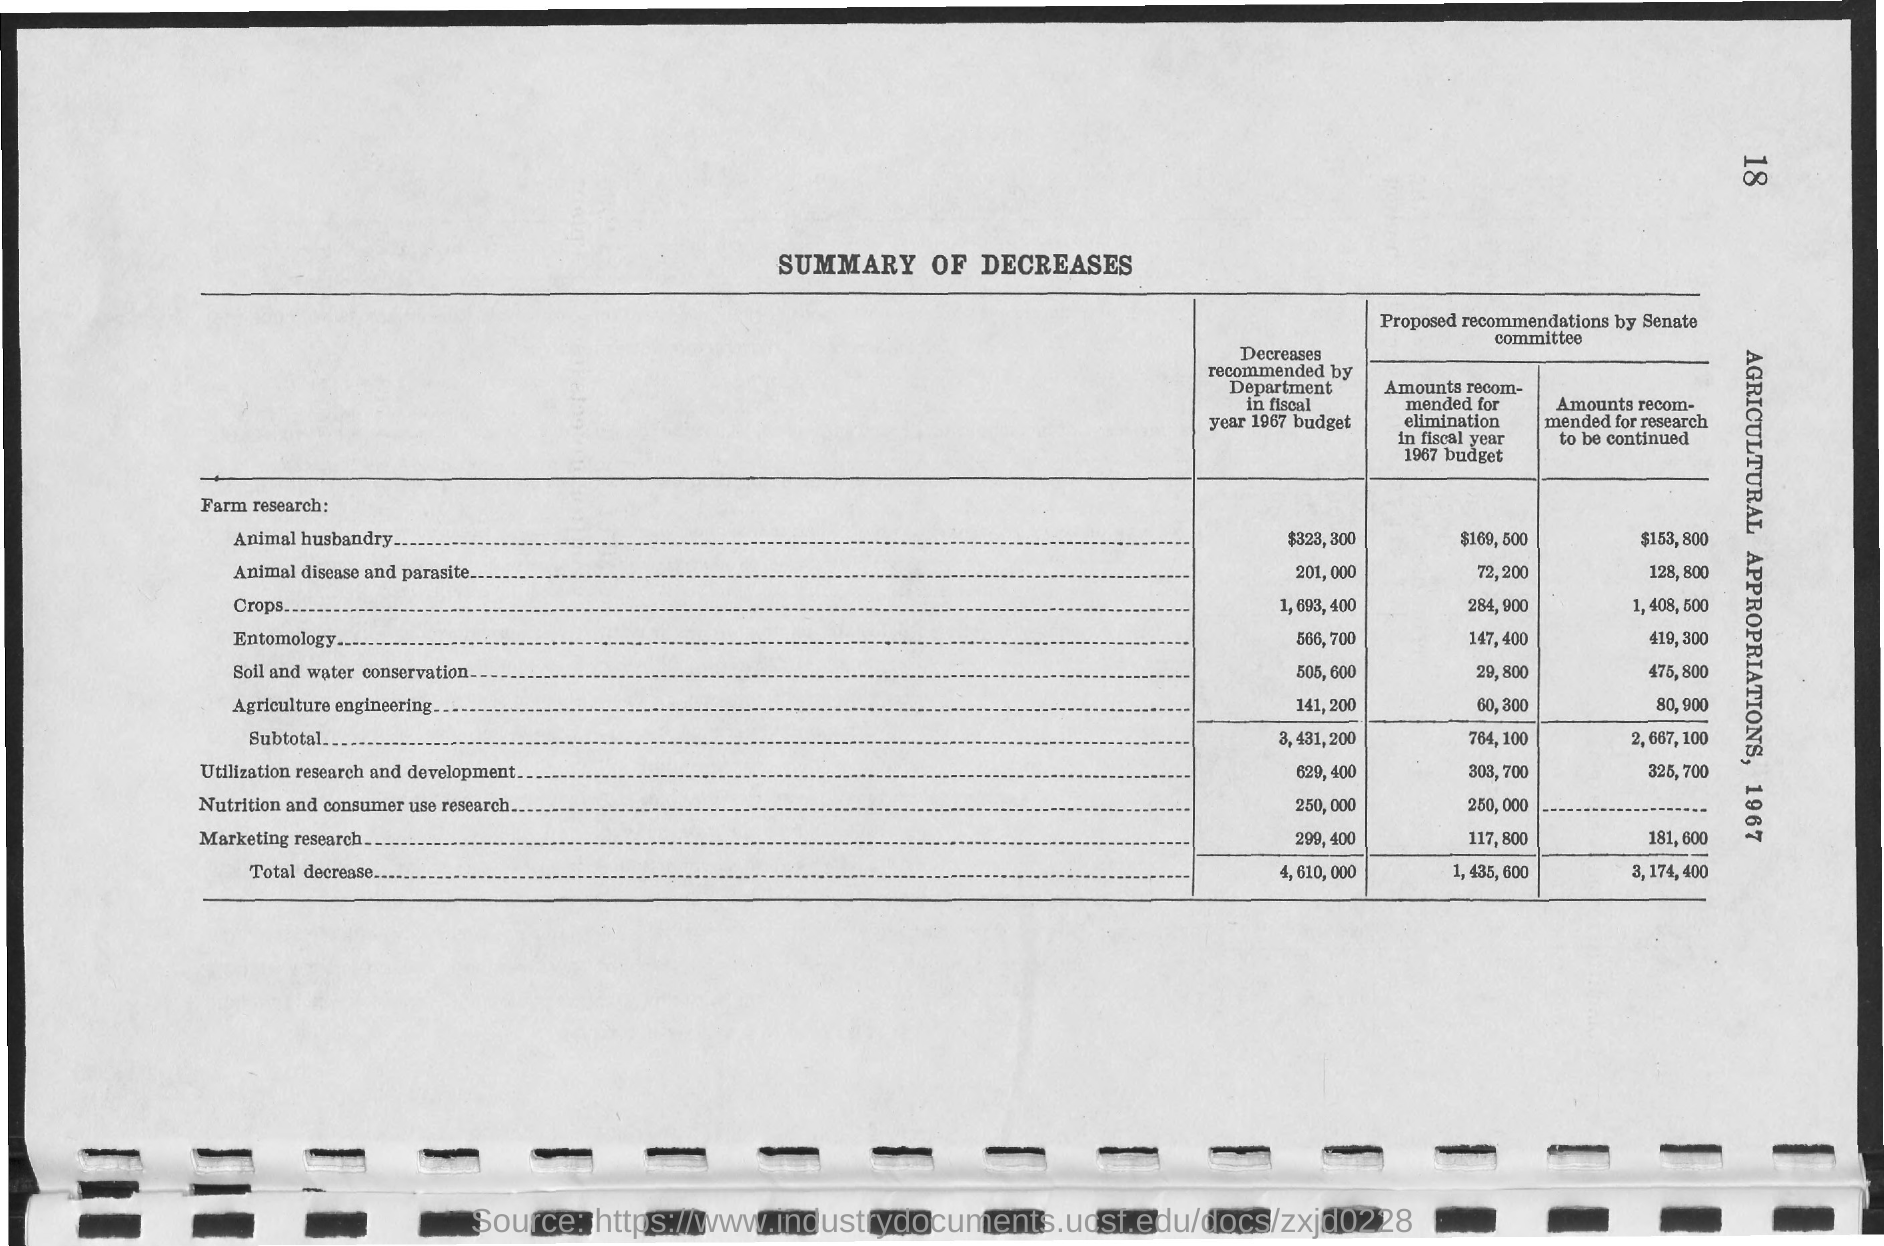Highlight a few significant elements in this photo. The page number is 18, as declared. The document is titled 'Summary of Decreases.' 